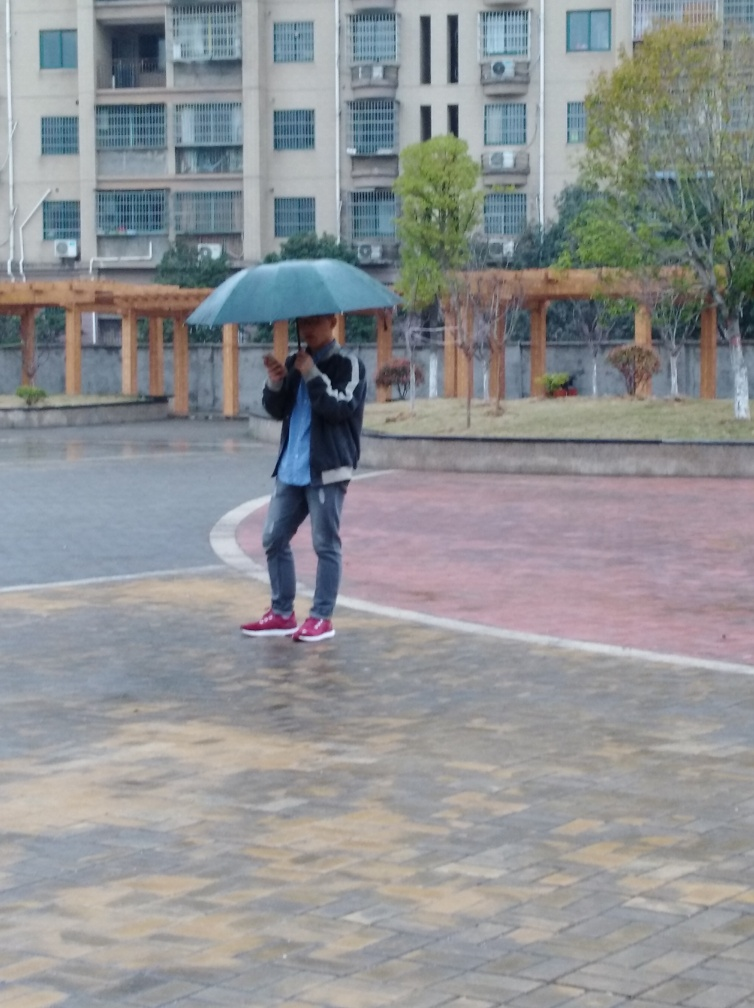How would you describe the overall lighting? The overall lighting in the image appears to be natural and diffused, likely from an overcast or cloudy sky. This kind of lighting results in soft shadows and even illumination, which can be seen on the ground and the person standing with an umbrella. There is no evidence of harsh or direct sunlight, and the atmosphere suggests it might be a wet or rainy day. 